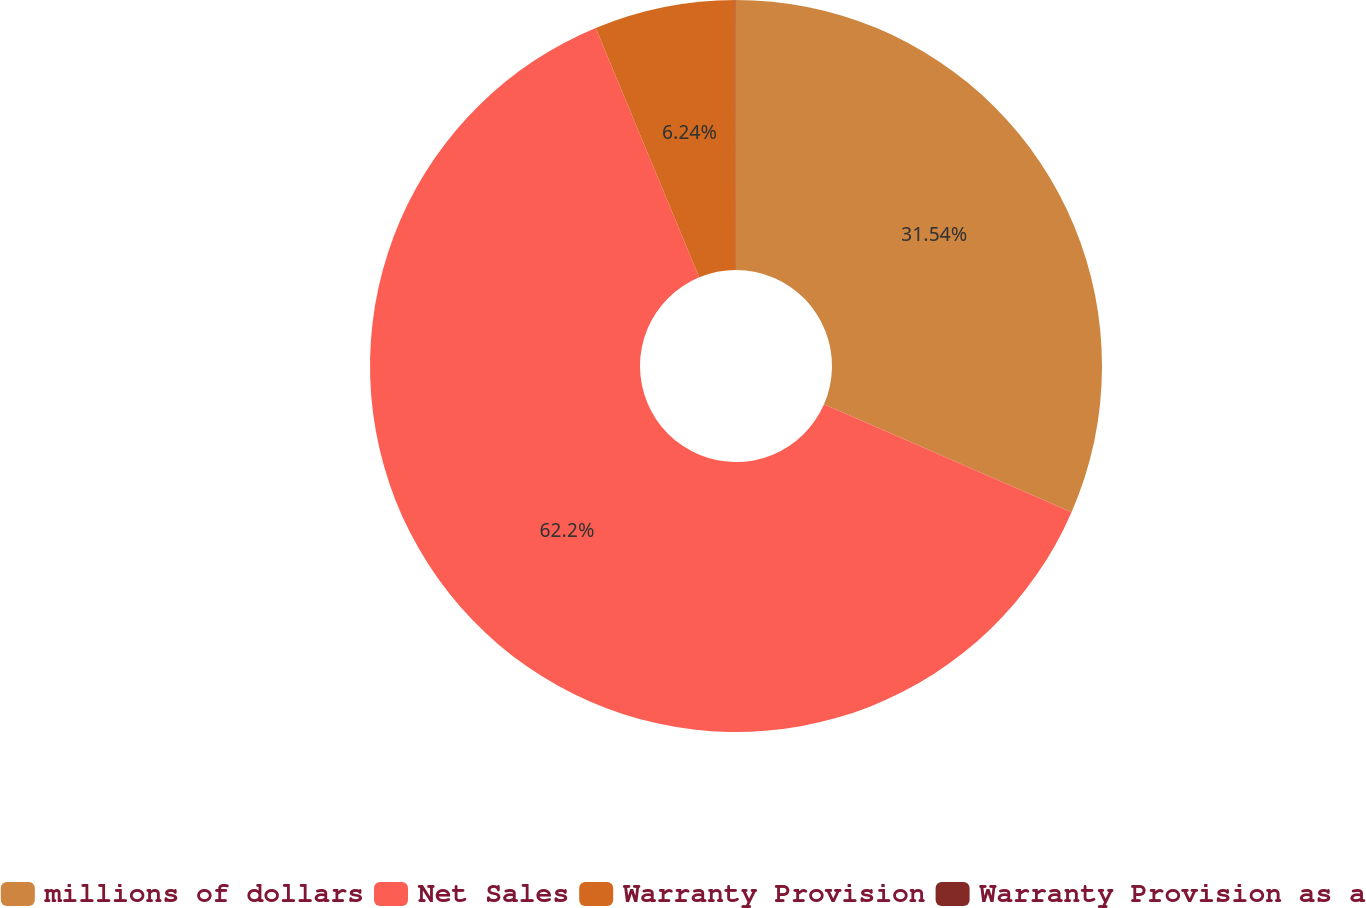Convert chart. <chart><loc_0><loc_0><loc_500><loc_500><pie_chart><fcel>millions of dollars<fcel>Net Sales<fcel>Warranty Provision<fcel>Warranty Provision as a<nl><fcel>31.54%<fcel>62.2%<fcel>6.24%<fcel>0.02%<nl></chart> 